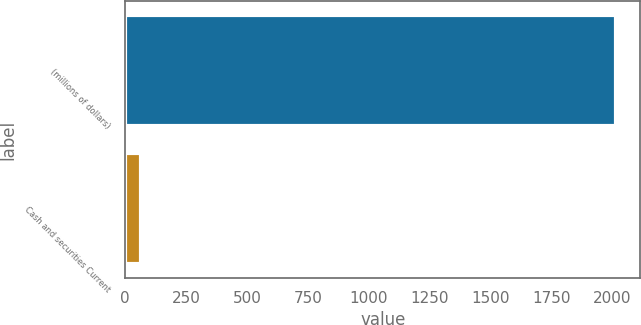Convert chart to OTSL. <chart><loc_0><loc_0><loc_500><loc_500><bar_chart><fcel>(millions of dollars)<fcel>Cash and securities Current<nl><fcel>2014<fcel>65.6<nl></chart> 